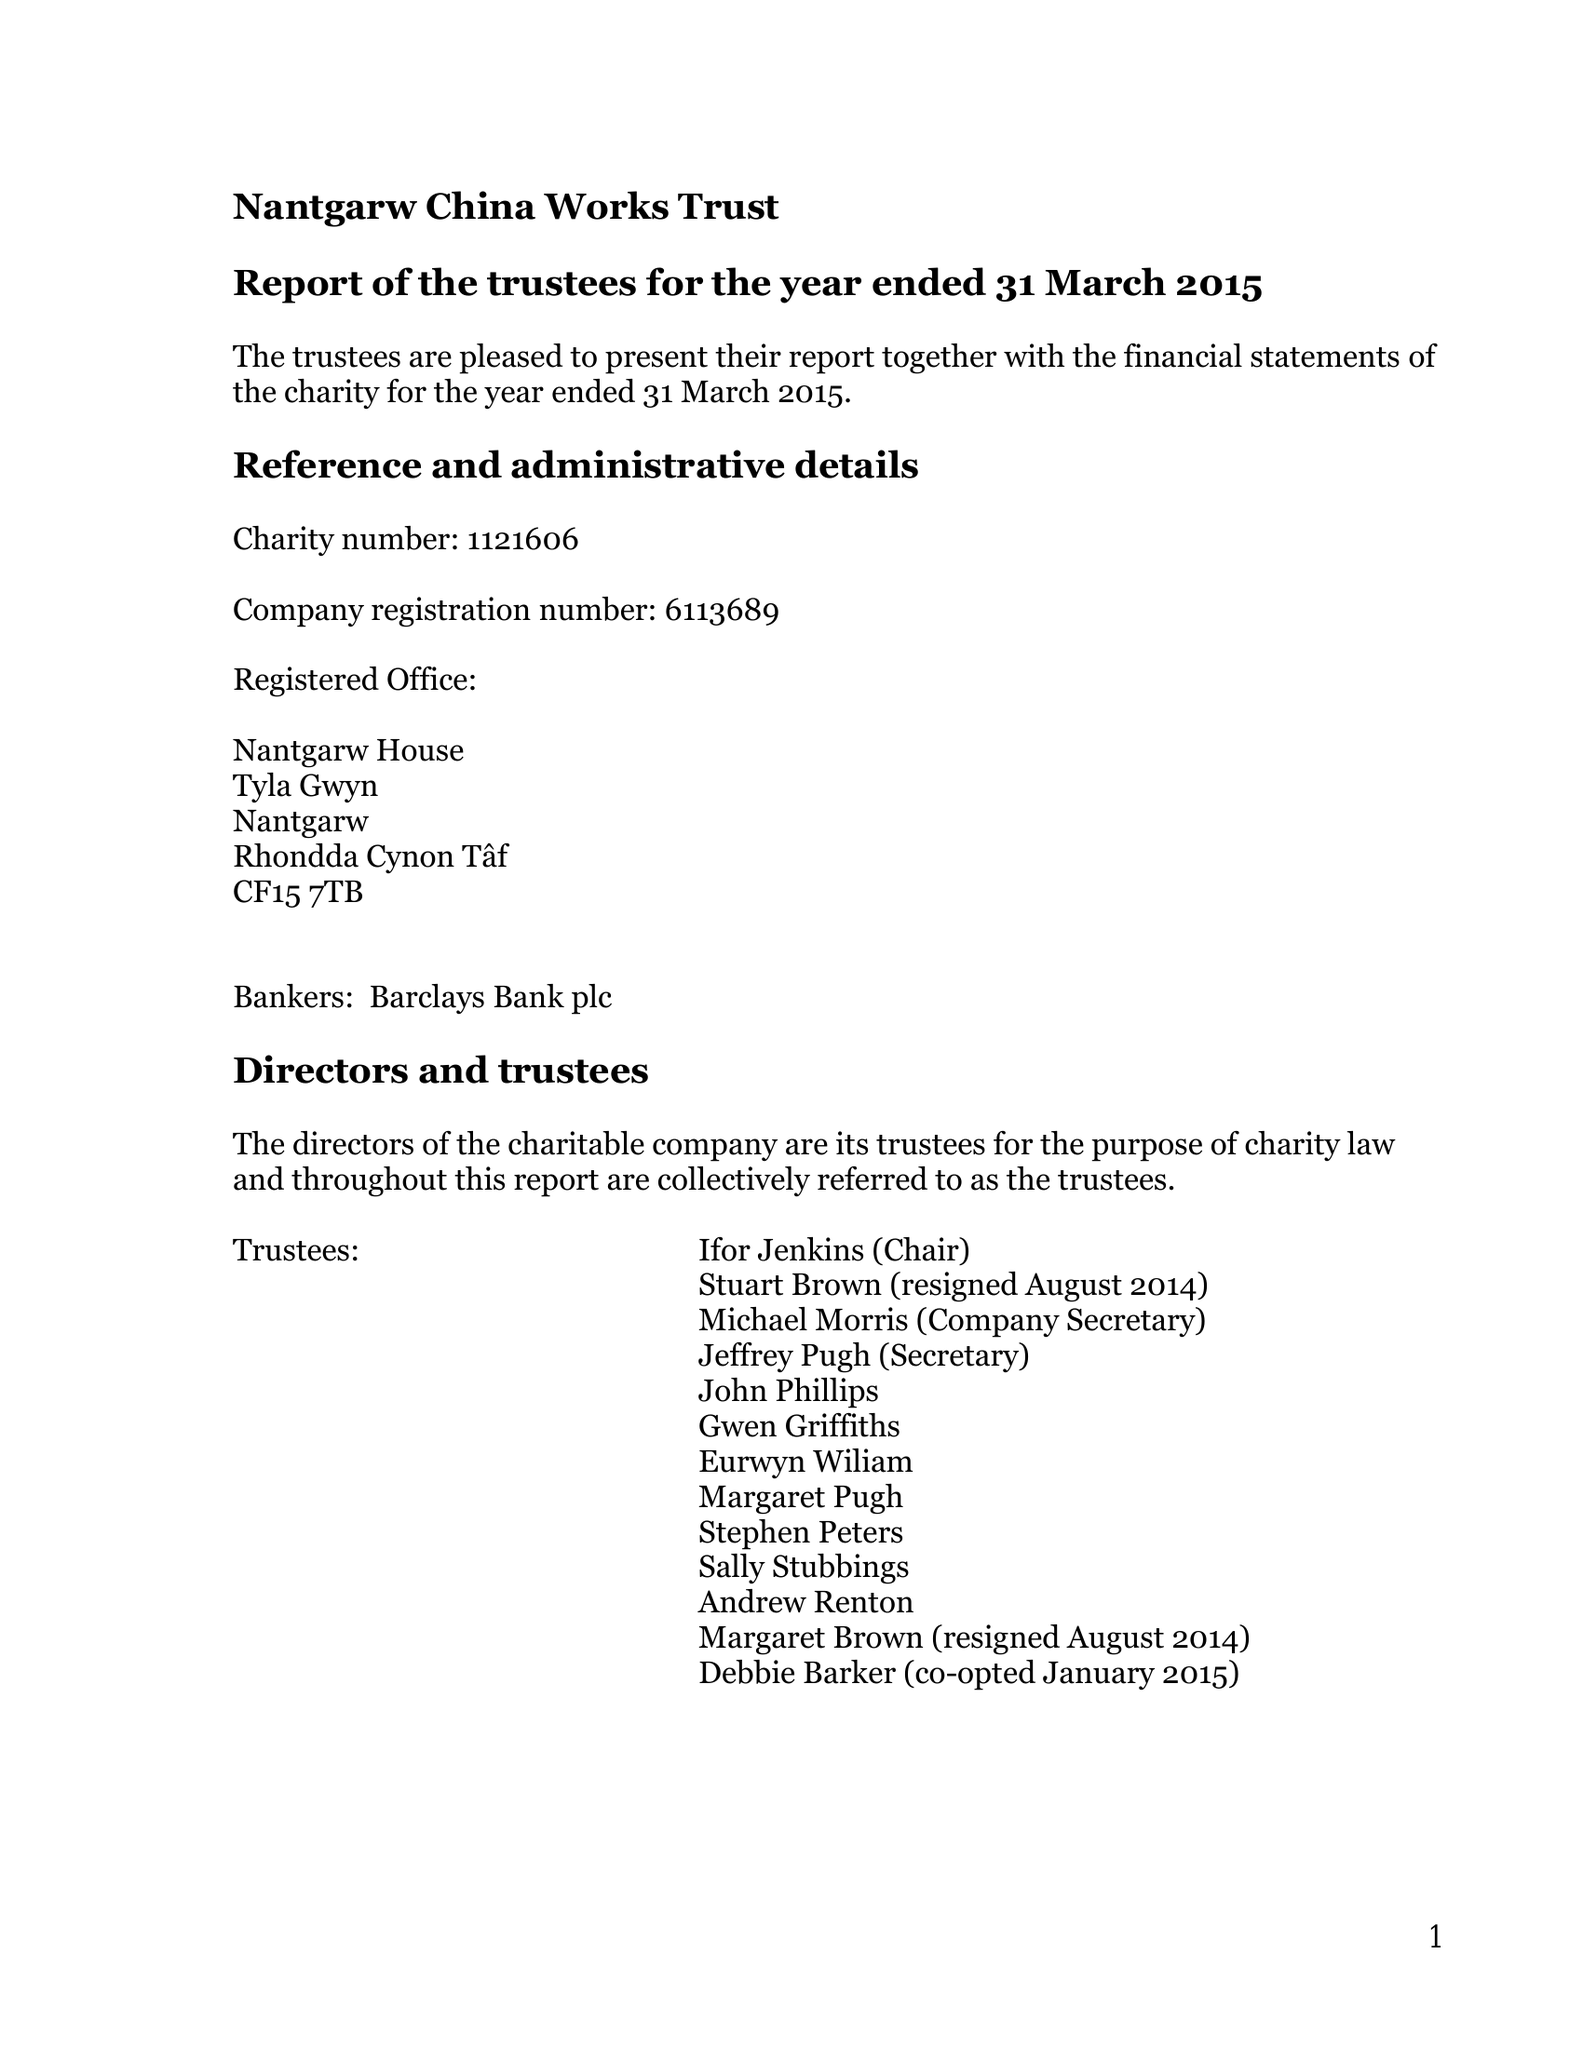What is the value for the report_date?
Answer the question using a single word or phrase. 2015-03-31 